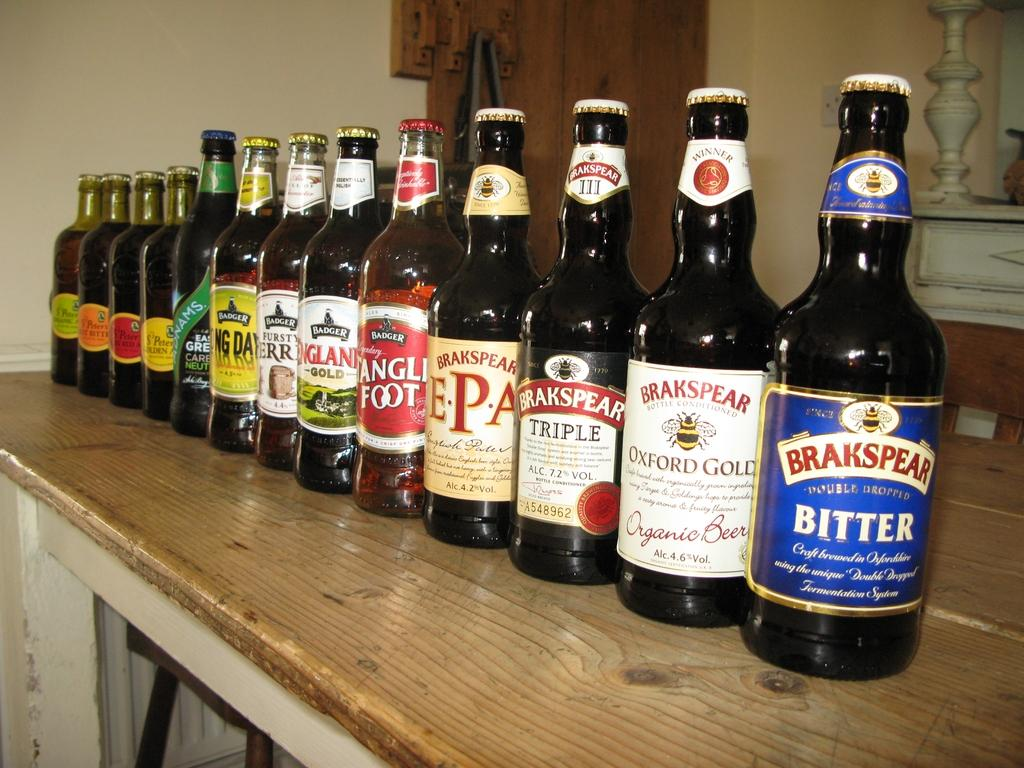<image>
Relay a brief, clear account of the picture shown. Many bottles of beer in a row with "Brakspear" beer in the front. 